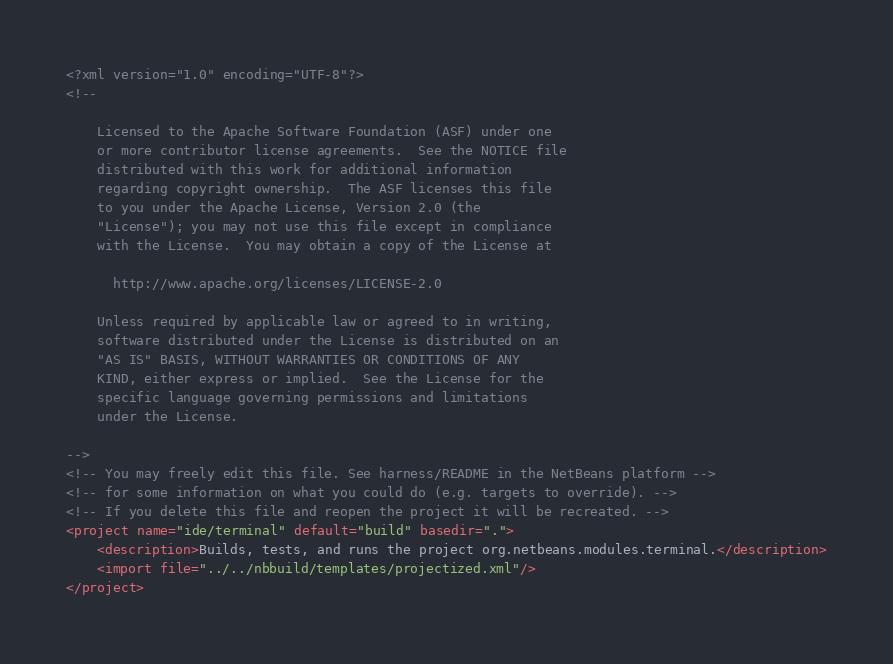Convert code to text. <code><loc_0><loc_0><loc_500><loc_500><_XML_><?xml version="1.0" encoding="UTF-8"?>
<!--

    Licensed to the Apache Software Foundation (ASF) under one
    or more contributor license agreements.  See the NOTICE file
    distributed with this work for additional information
    regarding copyright ownership.  The ASF licenses this file
    to you under the Apache License, Version 2.0 (the
    "License"); you may not use this file except in compliance
    with the License.  You may obtain a copy of the License at

      http://www.apache.org/licenses/LICENSE-2.0

    Unless required by applicable law or agreed to in writing,
    software distributed under the License is distributed on an
    "AS IS" BASIS, WITHOUT WARRANTIES OR CONDITIONS OF ANY
    KIND, either express or implied.  See the License for the
    specific language governing permissions and limitations
    under the License.

-->
<!-- You may freely edit this file. See harness/README in the NetBeans platform -->
<!-- for some information on what you could do (e.g. targets to override). -->
<!-- If you delete this file and reopen the project it will be recreated. -->
<project name="ide/terminal" default="build" basedir=".">
    <description>Builds, tests, and runs the project org.netbeans.modules.terminal.</description>
    <import file="../../nbbuild/templates/projectized.xml"/>
</project>
</code> 